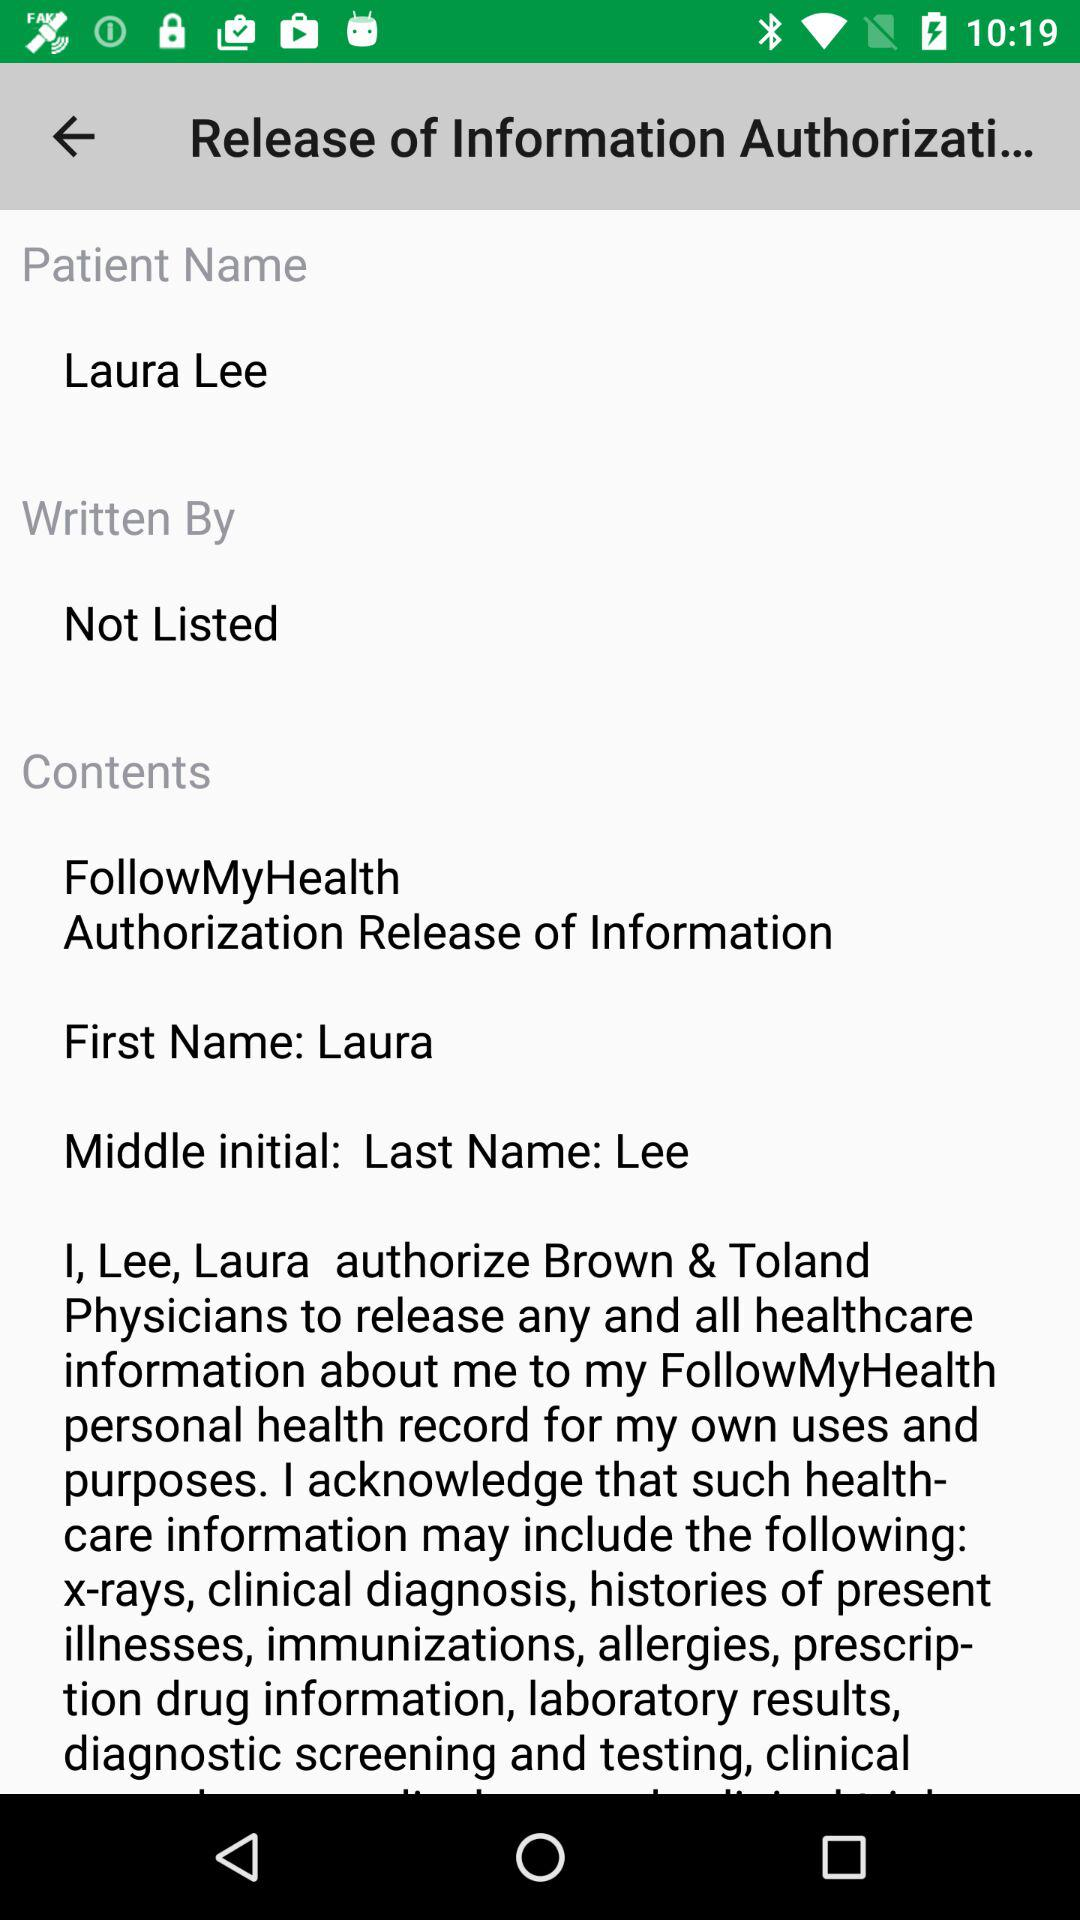What is the patient's name? The patient's name is Laura Lee. 